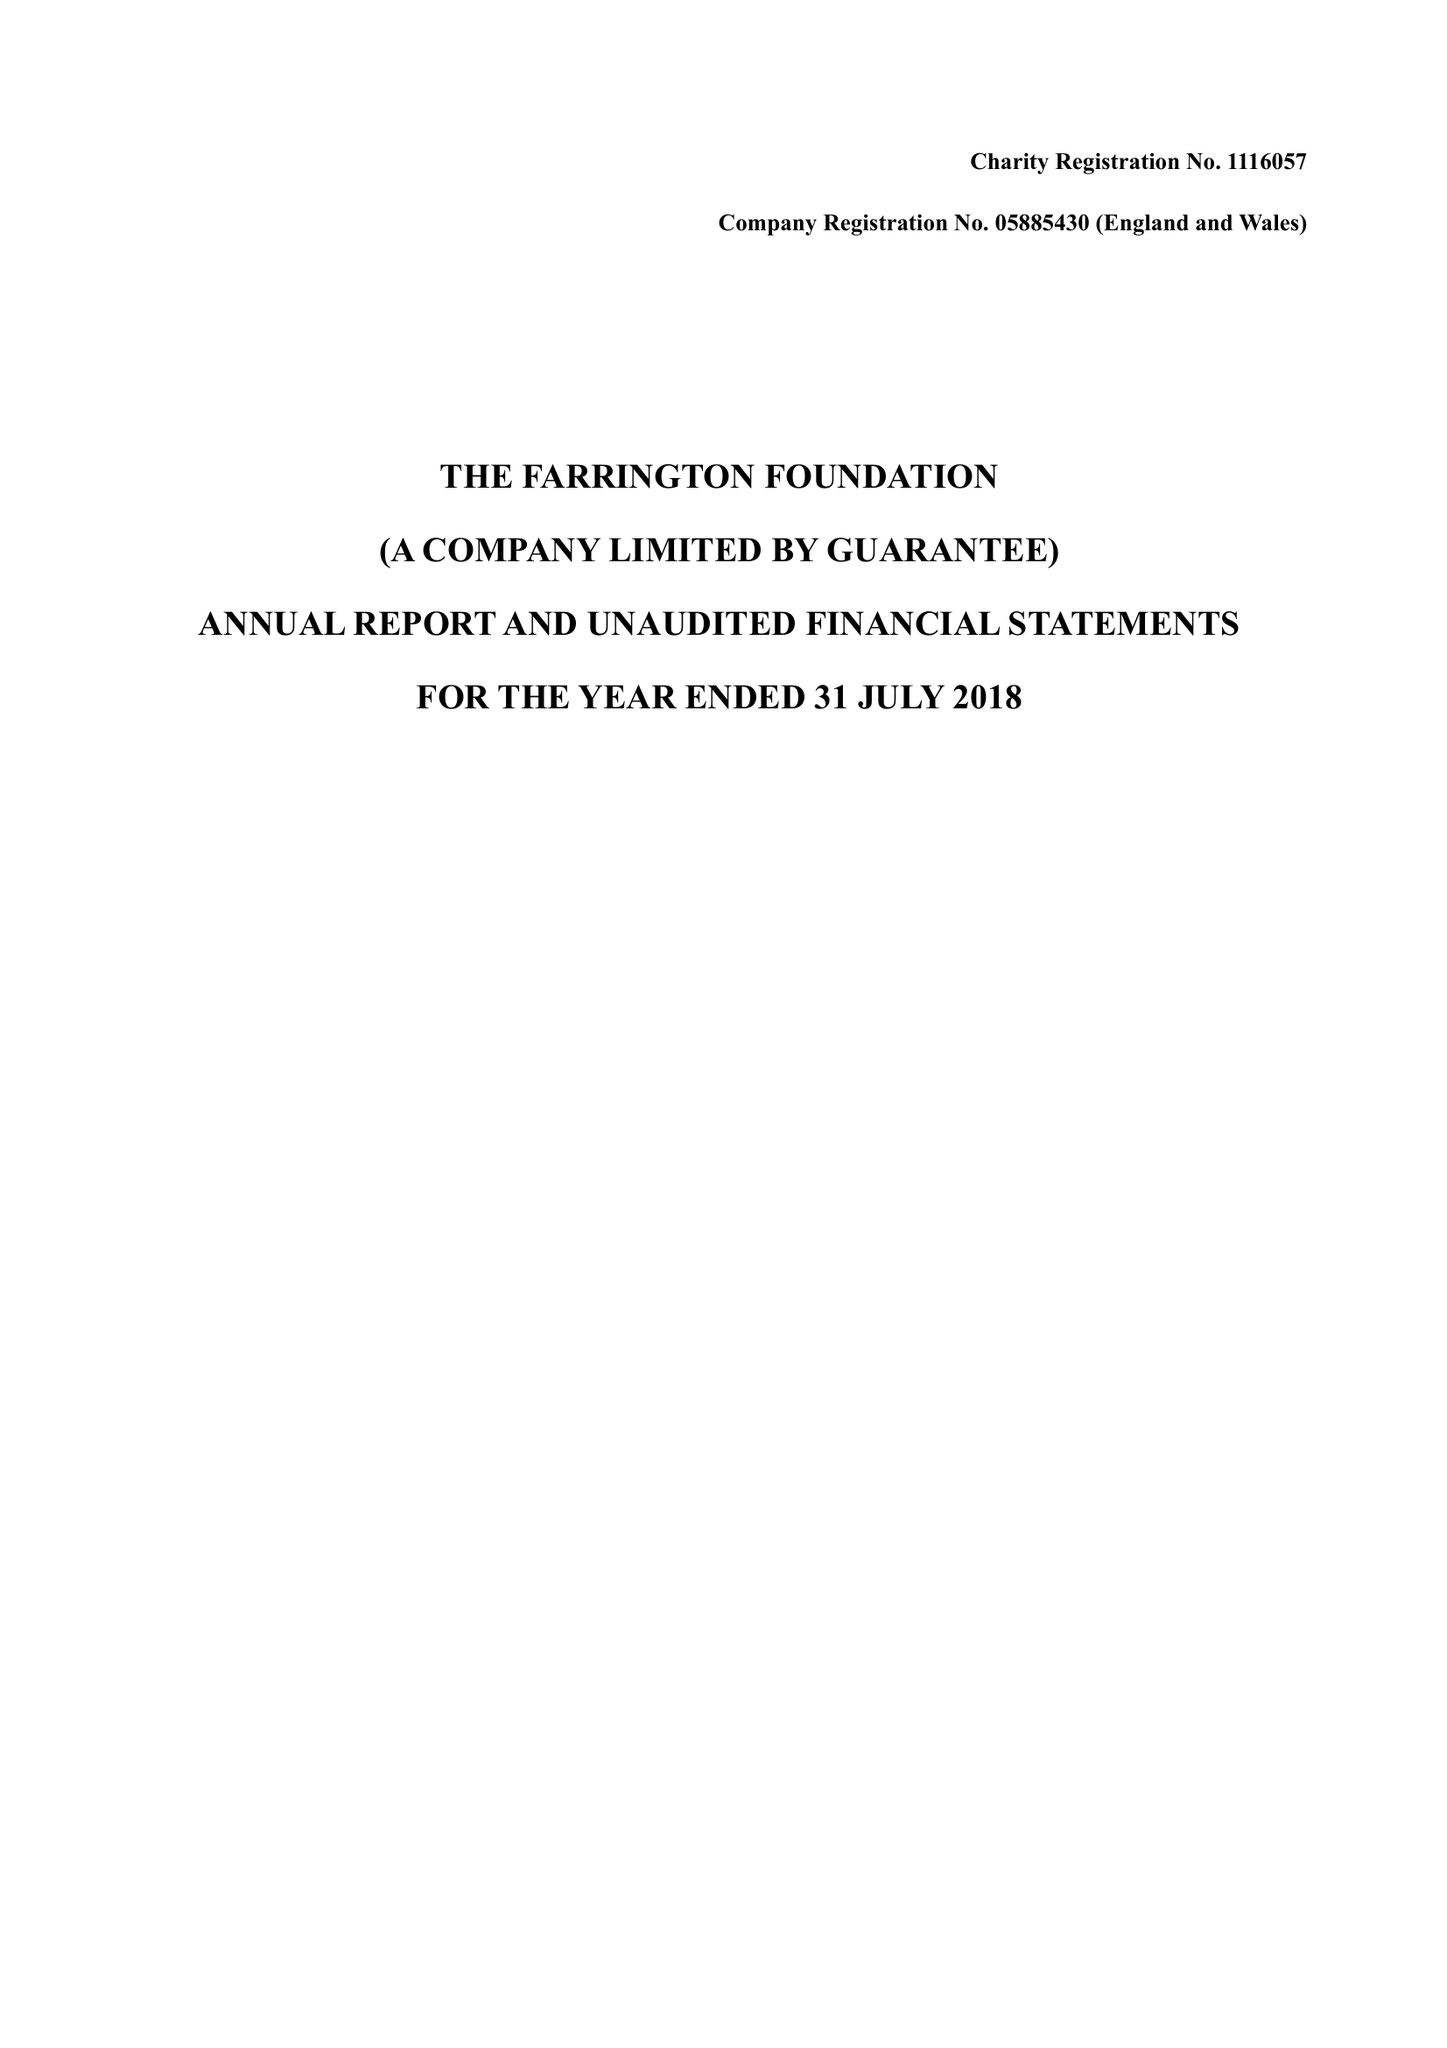What is the value for the income_annually_in_british_pounds?
Answer the question using a single word or phrase. 27122.00 